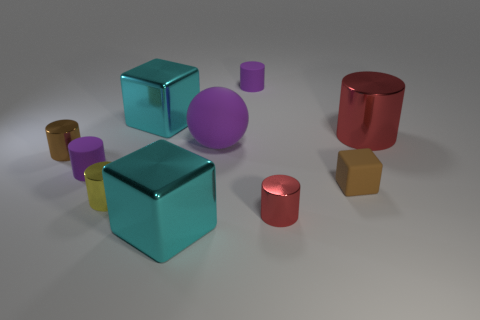Subtract all big metallic cylinders. How many cylinders are left? 5 Subtract all brown spheres. How many cyan cubes are left? 2 Subtract all yellow cylinders. How many cylinders are left? 5 Subtract all blocks. How many objects are left? 7 Subtract 2 blocks. How many blocks are left? 1 Subtract all brown balls. Subtract all green cylinders. How many balls are left? 1 Subtract all metal objects. Subtract all purple spheres. How many objects are left? 3 Add 7 small red metallic objects. How many small red metallic objects are left? 8 Add 6 small red metal cylinders. How many small red metal cylinders exist? 7 Subtract 0 yellow spheres. How many objects are left? 10 